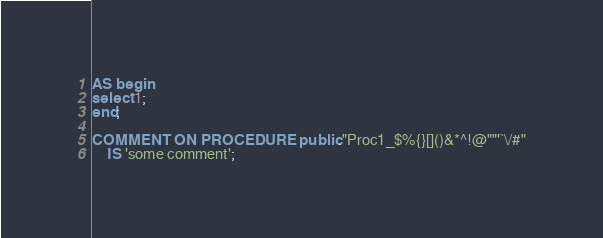Convert code to text. <code><loc_0><loc_0><loc_500><loc_500><_SQL_>AS begin
select 1;
end;

COMMENT ON PROCEDURE public."Proc1_$%{}[]()&*^!@""'`\/#"
    IS 'some comment';
</code> 